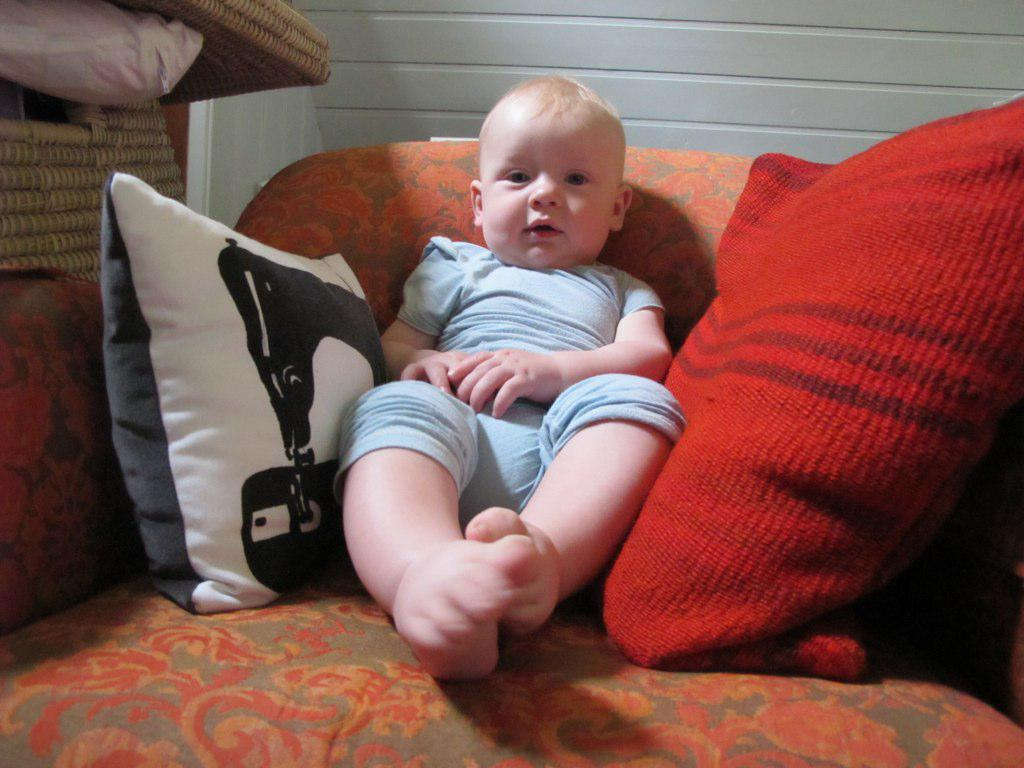What piece of furniture is in the image? There is a chair in the image. Who or what is on the chair? A child is sitting on the chair. Are there any additional items on the chair? Yes, there are pillows on the chair. What can be seen in the background of the image? There is a wall and some unspecified objects in the background of the image. What type of branch is the child climbing on the chair? There is no branch present in the image; the child is sitting on a chair with pillows. 